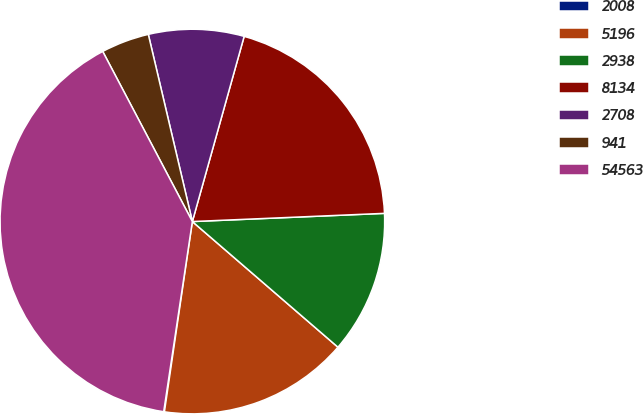<chart> <loc_0><loc_0><loc_500><loc_500><pie_chart><fcel>2008<fcel>5196<fcel>2938<fcel>8134<fcel>2708<fcel>941<fcel>54563<nl><fcel>0.06%<fcel>15.99%<fcel>12.01%<fcel>19.98%<fcel>8.02%<fcel>4.04%<fcel>39.9%<nl></chart> 